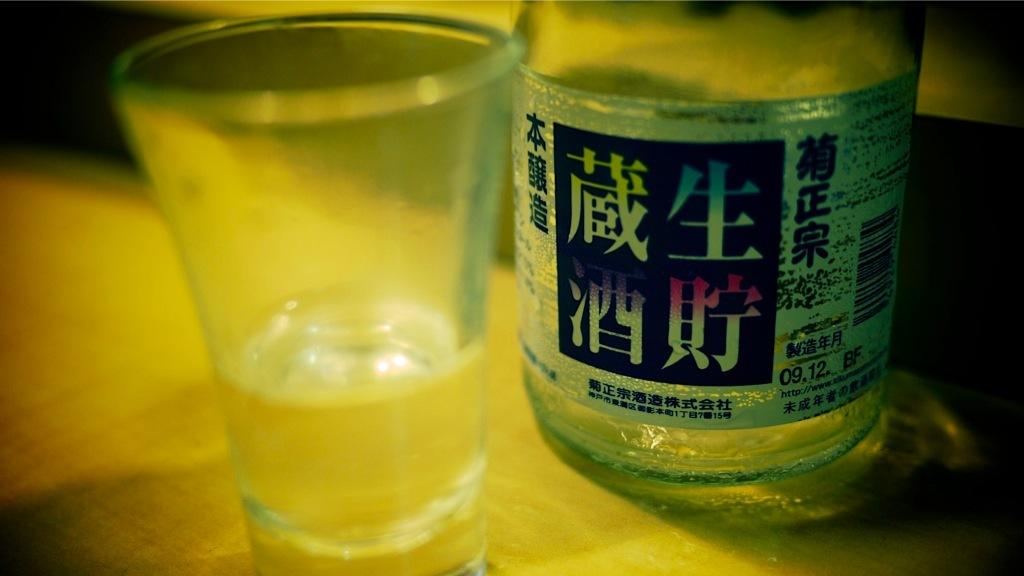<image>
Write a terse but informative summary of the picture. Bottle of a clear liquor that has in black writing 09.12. BF 